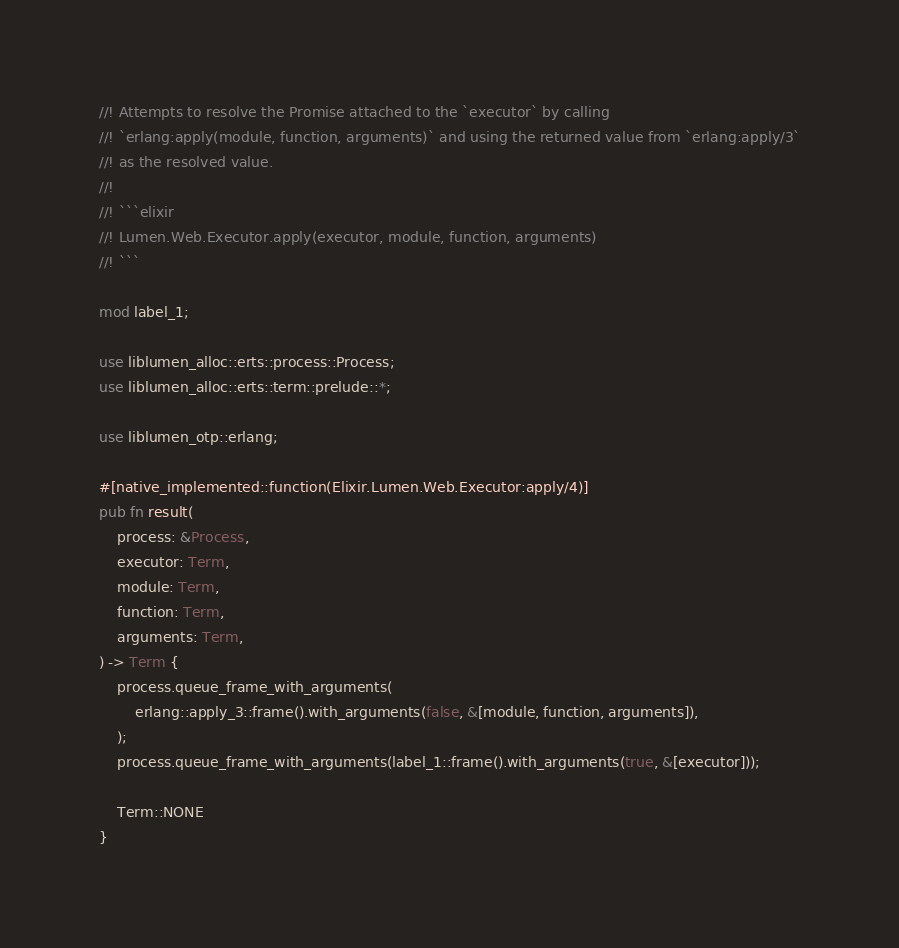<code> <loc_0><loc_0><loc_500><loc_500><_Rust_>//! Attempts to resolve the Promise attached to the `executor` by calling
//! `erlang:apply(module, function, arguments)` and using the returned value from `erlang:apply/3`
//! as the resolved value.
//!
//! ```elixir
//! Lumen.Web.Executor.apply(executor, module, function, arguments)
//! ```

mod label_1;

use liblumen_alloc::erts::process::Process;
use liblumen_alloc::erts::term::prelude::*;

use liblumen_otp::erlang;

#[native_implemented::function(Elixir.Lumen.Web.Executor:apply/4)]
pub fn result(
    process: &Process,
    executor: Term,
    module: Term,
    function: Term,
    arguments: Term,
) -> Term {
    process.queue_frame_with_arguments(
        erlang::apply_3::frame().with_arguments(false, &[module, function, arguments]),
    );
    process.queue_frame_with_arguments(label_1::frame().with_arguments(true, &[executor]));

    Term::NONE
}
</code> 